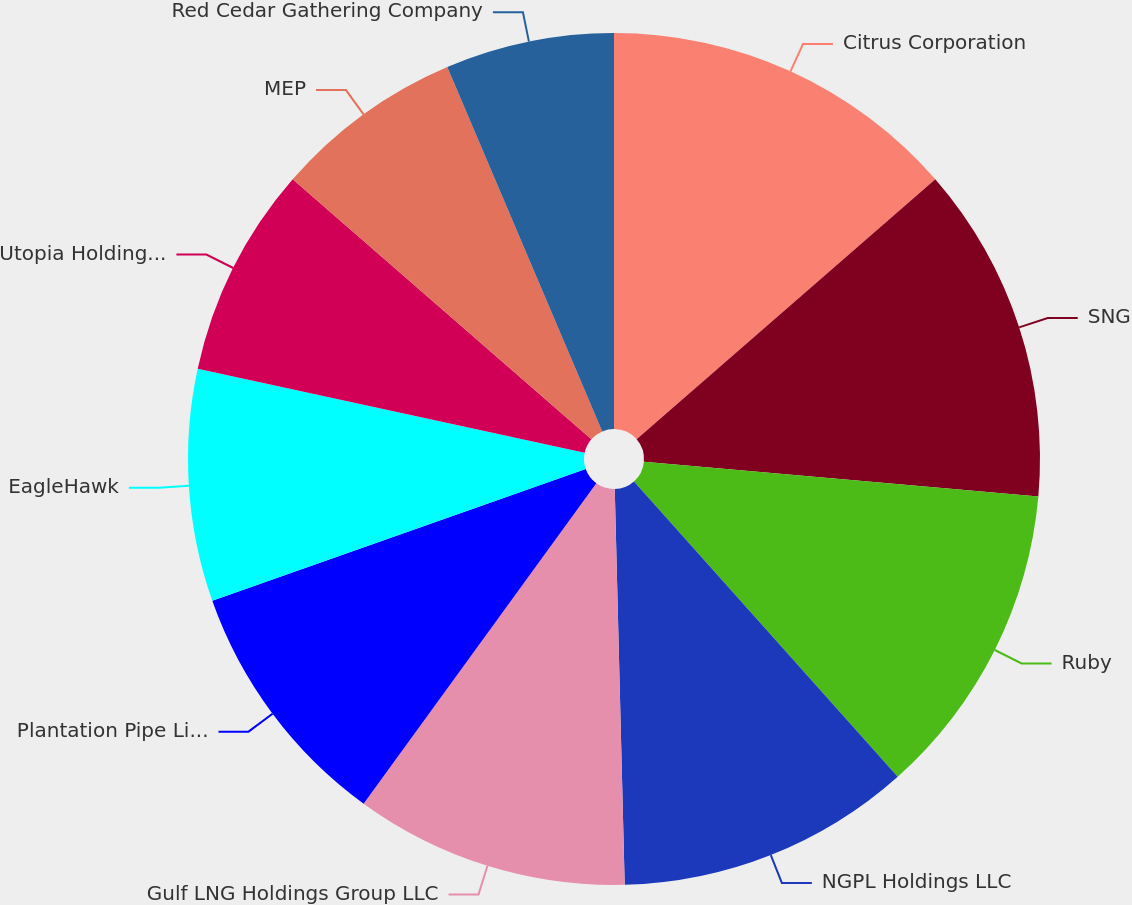Convert chart to OTSL. <chart><loc_0><loc_0><loc_500><loc_500><pie_chart><fcel>Citrus Corporation<fcel>SNG<fcel>Ruby<fcel>NGPL Holdings LLC<fcel>Gulf LNG Holdings Group LLC<fcel>Plantation Pipe Line Company<fcel>EagleHawk<fcel>Utopia Holding LLC<fcel>MEP<fcel>Red Cedar Gathering Company<nl><fcel>13.6%<fcel>12.8%<fcel>12.0%<fcel>11.2%<fcel>10.4%<fcel>9.6%<fcel>8.8%<fcel>8.0%<fcel>7.2%<fcel>6.4%<nl></chart> 